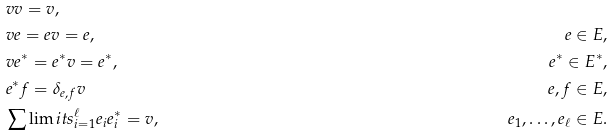Convert formula to latex. <formula><loc_0><loc_0><loc_500><loc_500>& v v = v , \\ & v e = e v = e , & e \in E , \\ & v e ^ { * } = e ^ { * } v = e ^ { * } , & e ^ { * } \in E ^ { * } , \\ & e ^ { * } f = \delta _ { e , f } v & e , f \in E , \\ & \sum \lim i t s _ { i = 1 } ^ { \ell } e _ { i } e _ { i } ^ { * } = v , & e _ { 1 } , \dots , e _ { \ell } \in E .</formula> 